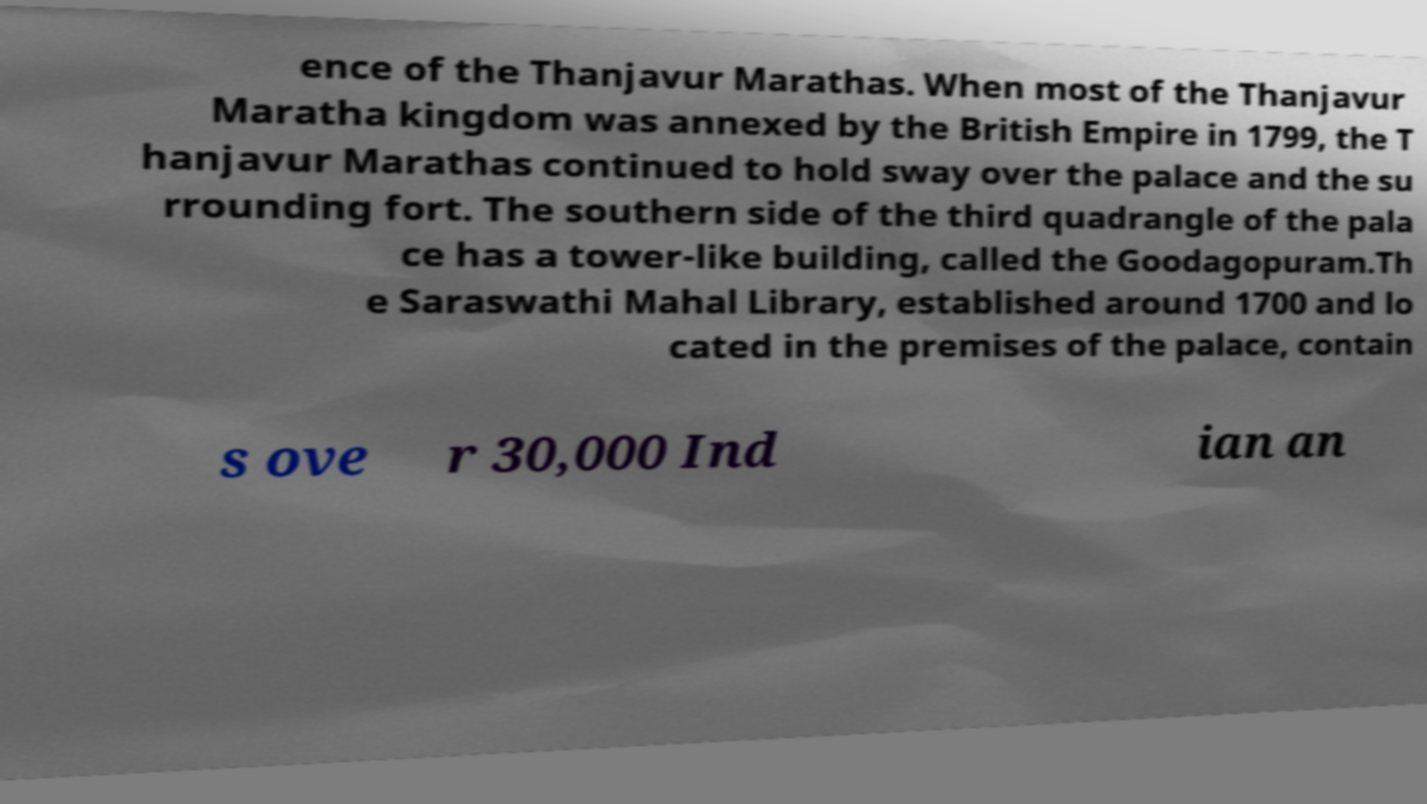I need the written content from this picture converted into text. Can you do that? ence of the Thanjavur Marathas. When most of the Thanjavur Maratha kingdom was annexed by the British Empire in 1799, the T hanjavur Marathas continued to hold sway over the palace and the su rrounding fort. The southern side of the third quadrangle of the pala ce has a tower-like building, called the Goodagopuram.Th e Saraswathi Mahal Library, established around 1700 and lo cated in the premises of the palace, contain s ove r 30,000 Ind ian an 